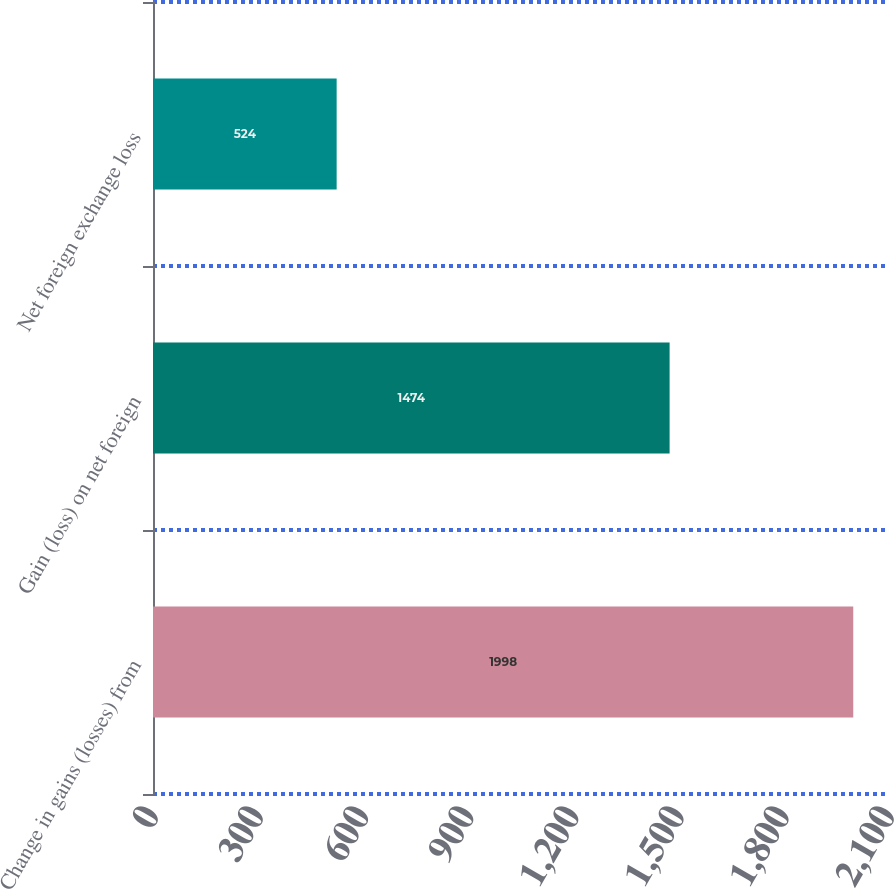<chart> <loc_0><loc_0><loc_500><loc_500><bar_chart><fcel>Change in gains (losses) from<fcel>Gain (loss) on net foreign<fcel>Net foreign exchange loss<nl><fcel>1998<fcel>1474<fcel>524<nl></chart> 